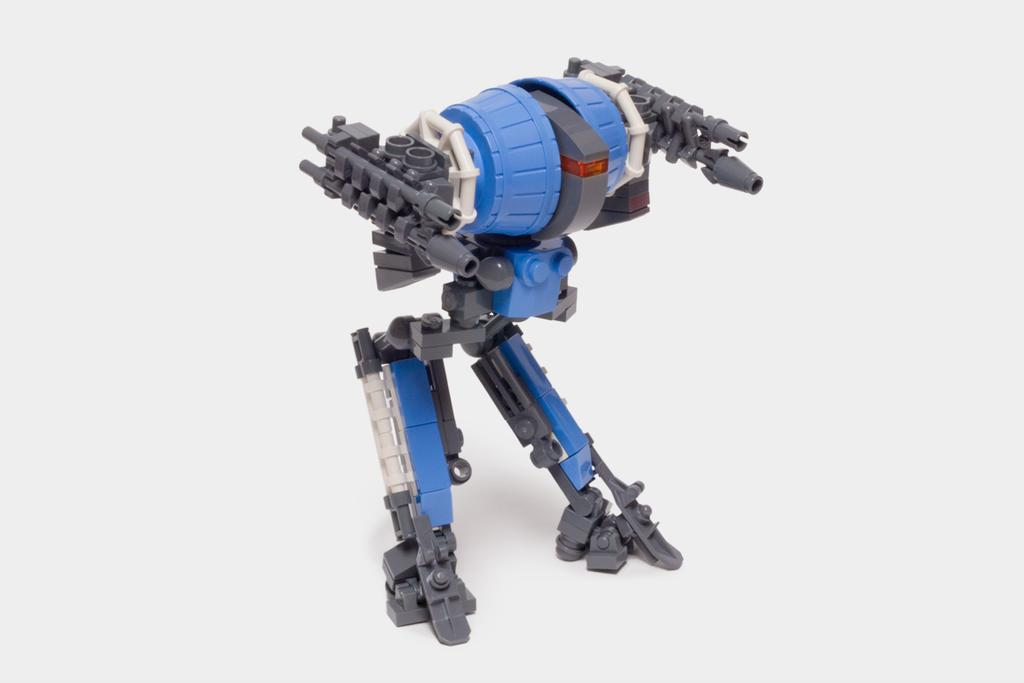What type of toy is in the image? There is a Lego toy in the image. What color is the background of the image? The background of the image is white. What type of soap is being used by the father during the rainstorm in the image? There is no soap, father, or rainstorm present in the image; it only features a Lego toy with a white background. 